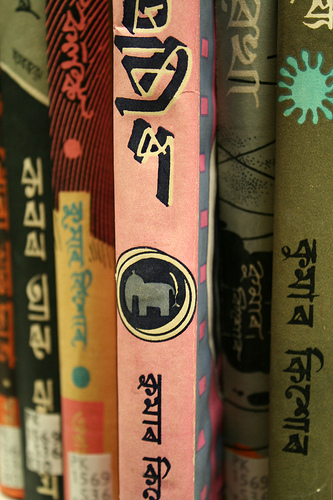<image>
Is the book to the left of the book? Yes. From this viewpoint, the book is positioned to the left side relative to the book. 